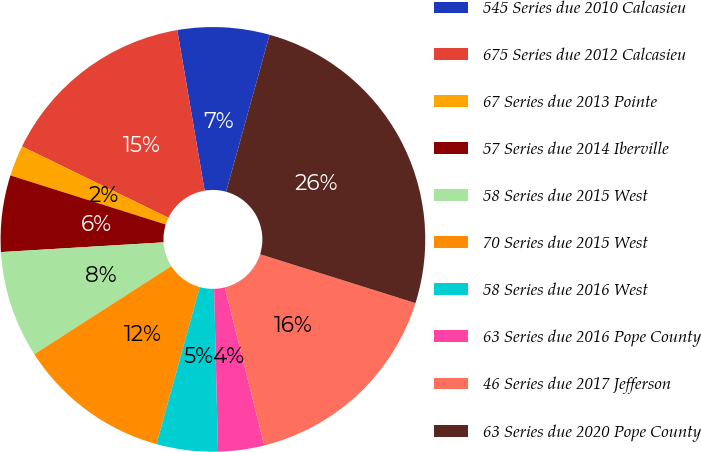Convert chart. <chart><loc_0><loc_0><loc_500><loc_500><pie_chart><fcel>545 Series due 2010 Calcasieu<fcel>675 Series due 2012 Calcasieu<fcel>67 Series due 2013 Pointe<fcel>57 Series due 2014 Iberville<fcel>58 Series due 2015 West<fcel>70 Series due 2015 West<fcel>58 Series due 2016 West<fcel>63 Series due 2016 Pope County<fcel>46 Series due 2017 Jefferson<fcel>63 Series due 2020 Pope County<nl><fcel>6.98%<fcel>15.1%<fcel>2.34%<fcel>5.82%<fcel>8.14%<fcel>11.62%<fcel>4.66%<fcel>3.5%<fcel>16.26%<fcel>25.54%<nl></chart> 